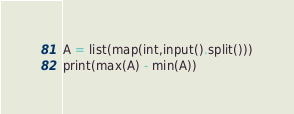<code> <loc_0><loc_0><loc_500><loc_500><_Python_>A = list(map(int,input().split()))
print(max(A) - min(A))</code> 